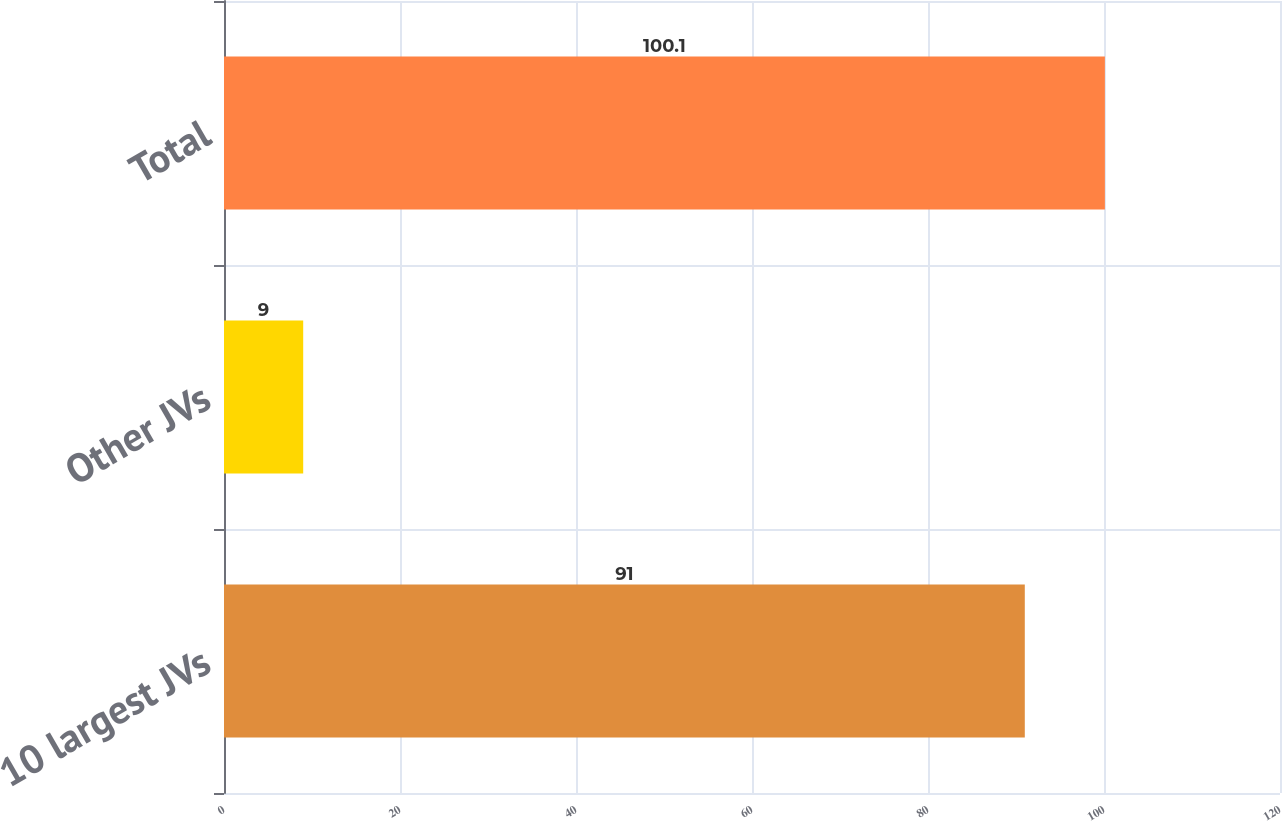Convert chart to OTSL. <chart><loc_0><loc_0><loc_500><loc_500><bar_chart><fcel>10 largest JVs<fcel>Other JVs<fcel>Total<nl><fcel>91<fcel>9<fcel>100.1<nl></chart> 